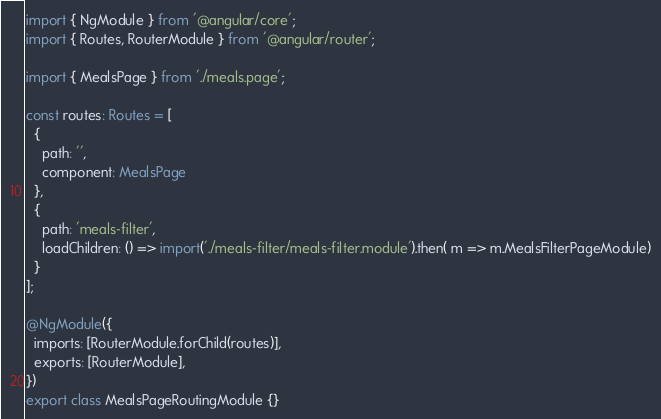<code> <loc_0><loc_0><loc_500><loc_500><_TypeScript_>import { NgModule } from '@angular/core';
import { Routes, RouterModule } from '@angular/router';

import { MealsPage } from './meals.page';

const routes: Routes = [
  {
    path: '',
    component: MealsPage
  },
  {
    path: 'meals-filter',
    loadChildren: () => import('./meals-filter/meals-filter.module').then( m => m.MealsFilterPageModule)
  }
];

@NgModule({
  imports: [RouterModule.forChild(routes)],
  exports: [RouterModule],
})
export class MealsPageRoutingModule {}
</code> 